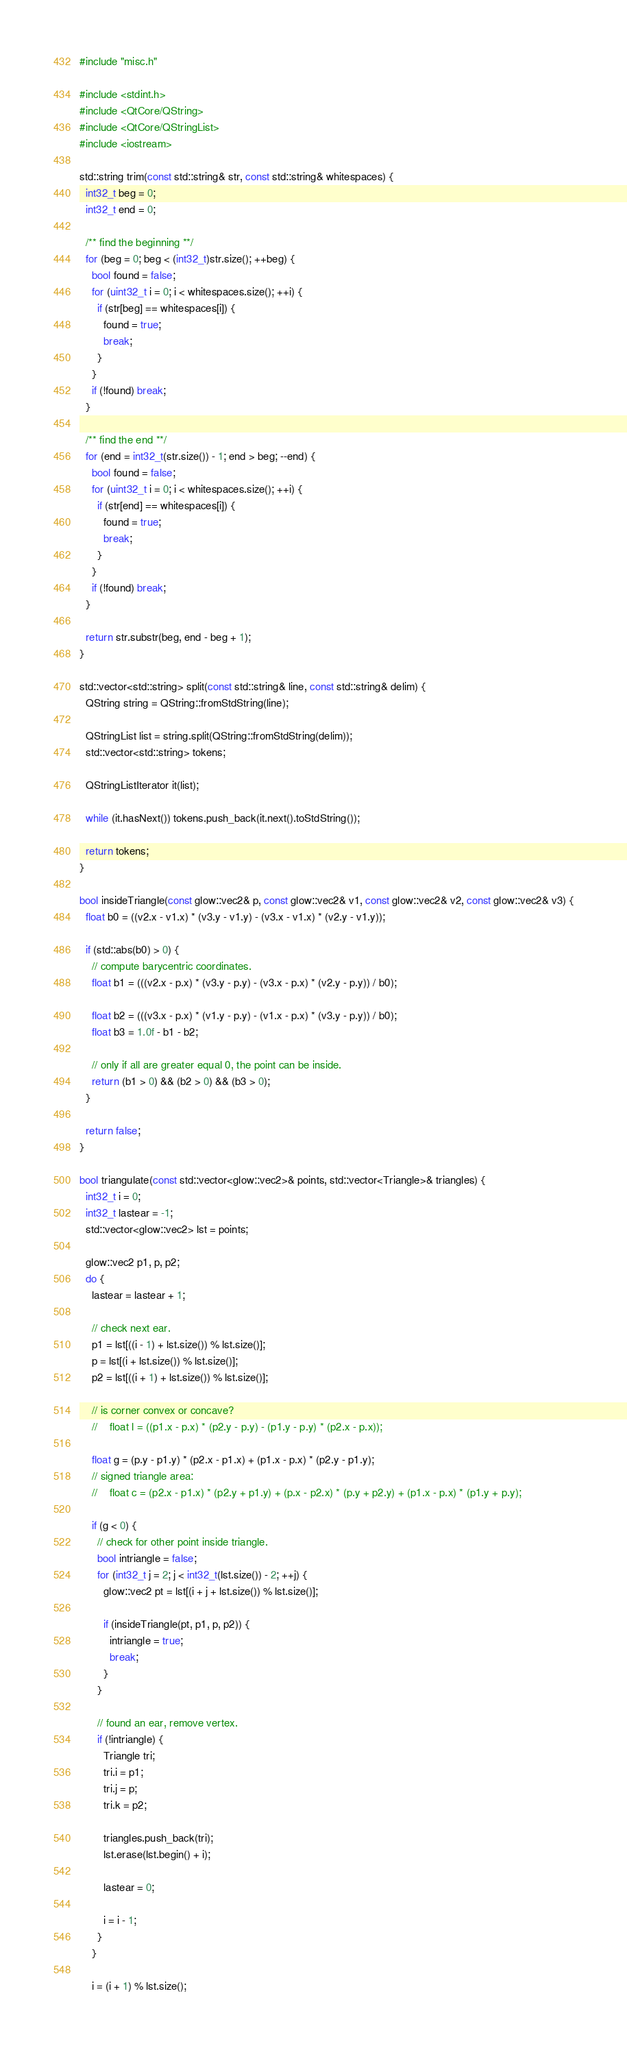<code> <loc_0><loc_0><loc_500><loc_500><_C++_>#include "misc.h"

#include <stdint.h>
#include <QtCore/QString>
#include <QtCore/QStringList>
#include <iostream>

std::string trim(const std::string& str, const std::string& whitespaces) {
  int32_t beg = 0;
  int32_t end = 0;

  /** find the beginning **/
  for (beg = 0; beg < (int32_t)str.size(); ++beg) {
    bool found = false;
    for (uint32_t i = 0; i < whitespaces.size(); ++i) {
      if (str[beg] == whitespaces[i]) {
        found = true;
        break;
      }
    }
    if (!found) break;
  }

  /** find the end **/
  for (end = int32_t(str.size()) - 1; end > beg; --end) {
    bool found = false;
    for (uint32_t i = 0; i < whitespaces.size(); ++i) {
      if (str[end] == whitespaces[i]) {
        found = true;
        break;
      }
    }
    if (!found) break;
  }

  return str.substr(beg, end - beg + 1);
}

std::vector<std::string> split(const std::string& line, const std::string& delim) {
  QString string = QString::fromStdString(line);

  QStringList list = string.split(QString::fromStdString(delim));
  std::vector<std::string> tokens;

  QStringListIterator it(list);

  while (it.hasNext()) tokens.push_back(it.next().toStdString());

  return tokens;
}

bool insideTriangle(const glow::vec2& p, const glow::vec2& v1, const glow::vec2& v2, const glow::vec2& v3) {
  float b0 = ((v2.x - v1.x) * (v3.y - v1.y) - (v3.x - v1.x) * (v2.y - v1.y));

  if (std::abs(b0) > 0) {
    // compute barycentric coordinates.
    float b1 = (((v2.x - p.x) * (v3.y - p.y) - (v3.x - p.x) * (v2.y - p.y)) / b0);

    float b2 = (((v3.x - p.x) * (v1.y - p.y) - (v1.x - p.x) * (v3.y - p.y)) / b0);
    float b3 = 1.0f - b1 - b2;

    // only if all are greater equal 0, the point can be inside.
    return (b1 > 0) && (b2 > 0) && (b3 > 0);
  }

  return false;
}

bool triangulate(const std::vector<glow::vec2>& points, std::vector<Triangle>& triangles) {
  int32_t i = 0;
  int32_t lastear = -1;
  std::vector<glow::vec2> lst = points;

  glow::vec2 p1, p, p2;
  do {
    lastear = lastear + 1;

    // check next ear.
    p1 = lst[((i - 1) + lst.size()) % lst.size()];
    p = lst[(i + lst.size()) % lst.size()];
    p2 = lst[((i + 1) + lst.size()) % lst.size()];

    // is corner convex or concave?
    //    float l = ((p1.x - p.x) * (p2.y - p.y) - (p1.y - p.y) * (p2.x - p.x));

    float g = (p.y - p1.y) * (p2.x - p1.x) + (p1.x - p.x) * (p2.y - p1.y);
    // signed triangle area:
    //    float c = (p2.x - p1.x) * (p2.y + p1.y) + (p.x - p2.x) * (p.y + p2.y) + (p1.x - p.x) * (p1.y + p.y);

    if (g < 0) {
      // check for other point inside triangle.
      bool intriangle = false;
      for (int32_t j = 2; j < int32_t(lst.size()) - 2; ++j) {
        glow::vec2 pt = lst[(i + j + lst.size()) % lst.size()];

        if (insideTriangle(pt, p1, p, p2)) {
          intriangle = true;
          break;
        }
      }

      // found an ear, remove vertex.
      if (!intriangle) {
        Triangle tri;
        tri.i = p1;
        tri.j = p;
        tri.k = p2;

        triangles.push_back(tri);
        lst.erase(lst.begin() + i);

        lastear = 0;

        i = i - 1;
      }
    }

    i = (i + 1) % lst.size();</code> 